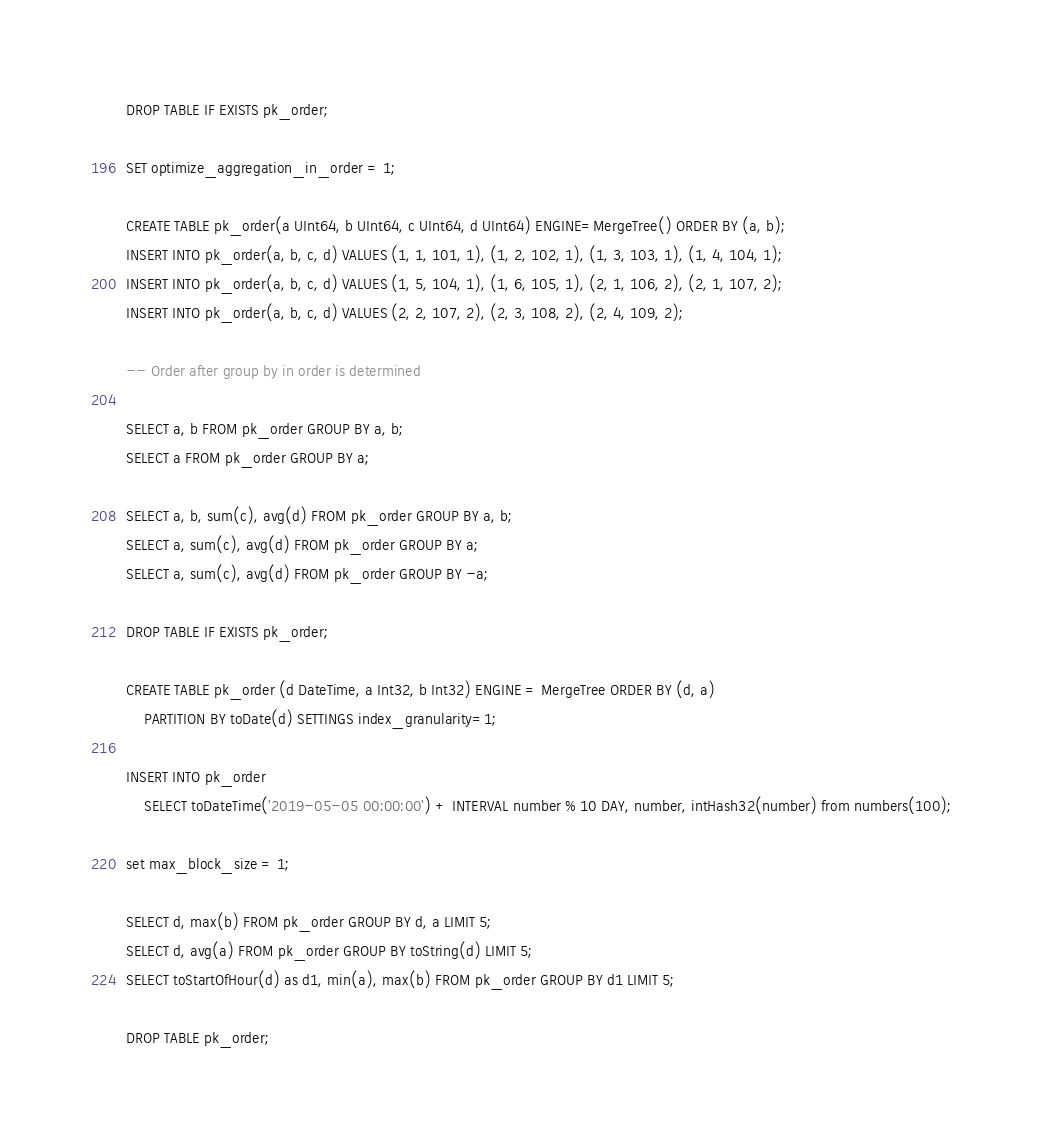<code> <loc_0><loc_0><loc_500><loc_500><_SQL_>DROP TABLE IF EXISTS pk_order;

SET optimize_aggregation_in_order = 1;

CREATE TABLE pk_order(a UInt64, b UInt64, c UInt64, d UInt64) ENGINE=MergeTree() ORDER BY (a, b);
INSERT INTO pk_order(a, b, c, d) VALUES (1, 1, 101, 1), (1, 2, 102, 1), (1, 3, 103, 1), (1, 4, 104, 1);
INSERT INTO pk_order(a, b, c, d) VALUES (1, 5, 104, 1), (1, 6, 105, 1), (2, 1, 106, 2), (2, 1, 107, 2);
INSERT INTO pk_order(a, b, c, d) VALUES (2, 2, 107, 2), (2, 3, 108, 2), (2, 4, 109, 2);

-- Order after group by in order is determined

SELECT a, b FROM pk_order GROUP BY a, b;
SELECT a FROM pk_order GROUP BY a;

SELECT a, b, sum(c), avg(d) FROM pk_order GROUP BY a, b;
SELECT a, sum(c), avg(d) FROM pk_order GROUP BY a;
SELECT a, sum(c), avg(d) FROM pk_order GROUP BY -a;

DROP TABLE IF EXISTS pk_order;

CREATE TABLE pk_order (d DateTime, a Int32, b Int32) ENGINE = MergeTree ORDER BY (d, a)
    PARTITION BY toDate(d) SETTINGS index_granularity=1;

INSERT INTO pk_order
    SELECT toDateTime('2019-05-05 00:00:00') + INTERVAL number % 10 DAY, number, intHash32(number) from numbers(100);

set max_block_size = 1;

SELECT d, max(b) FROM pk_order GROUP BY d, a LIMIT 5;
SELECT d, avg(a) FROM pk_order GROUP BY toString(d) LIMIT 5;
SELECT toStartOfHour(d) as d1, min(a), max(b) FROM pk_order GROUP BY d1 LIMIT 5;

DROP TABLE pk_order;
</code> 